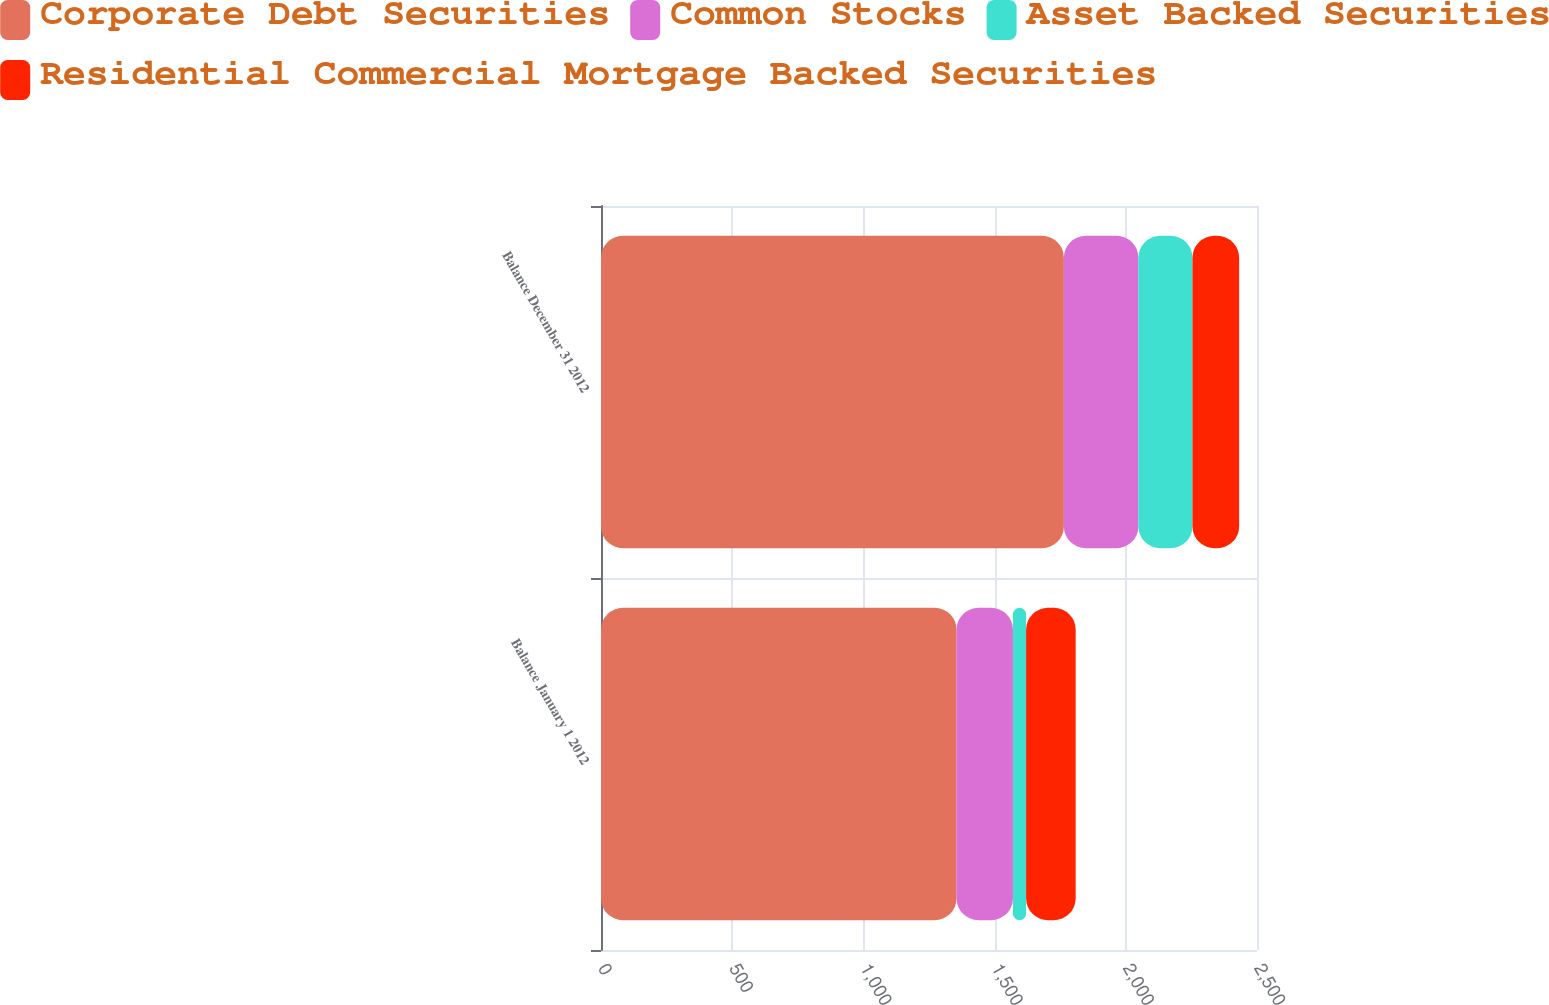<chart> <loc_0><loc_0><loc_500><loc_500><stacked_bar_chart><ecel><fcel>Balance January 1 2012<fcel>Balance December 31 2012<nl><fcel>Corporate Debt Securities<fcel>1355<fcel>1764<nl><fcel>Common Stocks<fcel>215<fcel>284<nl><fcel>Asset Backed Securities<fcel>50<fcel>206<nl><fcel>Residential Commercial Mortgage Backed Securities<fcel>189<fcel>178<nl></chart> 